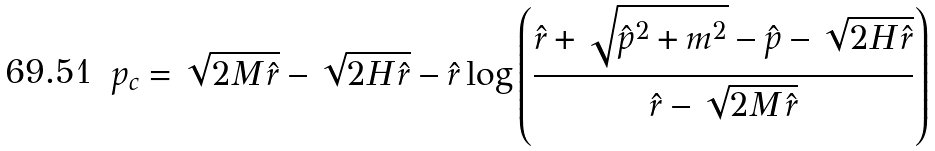Convert formula to latex. <formula><loc_0><loc_0><loc_500><loc_500>p _ { c } = \sqrt { 2 M \, \hat { r } } - \sqrt { 2 H \, \hat { r } } - \hat { r } \log \left ( \frac { \hat { r } + \sqrt { { \hat { p } } ^ { 2 } + m ^ { 2 } } - \hat { p } - \sqrt { 2 H \, \hat { r } } } { \hat { r } - \sqrt { 2 M \, \hat { r } } } \right )</formula> 